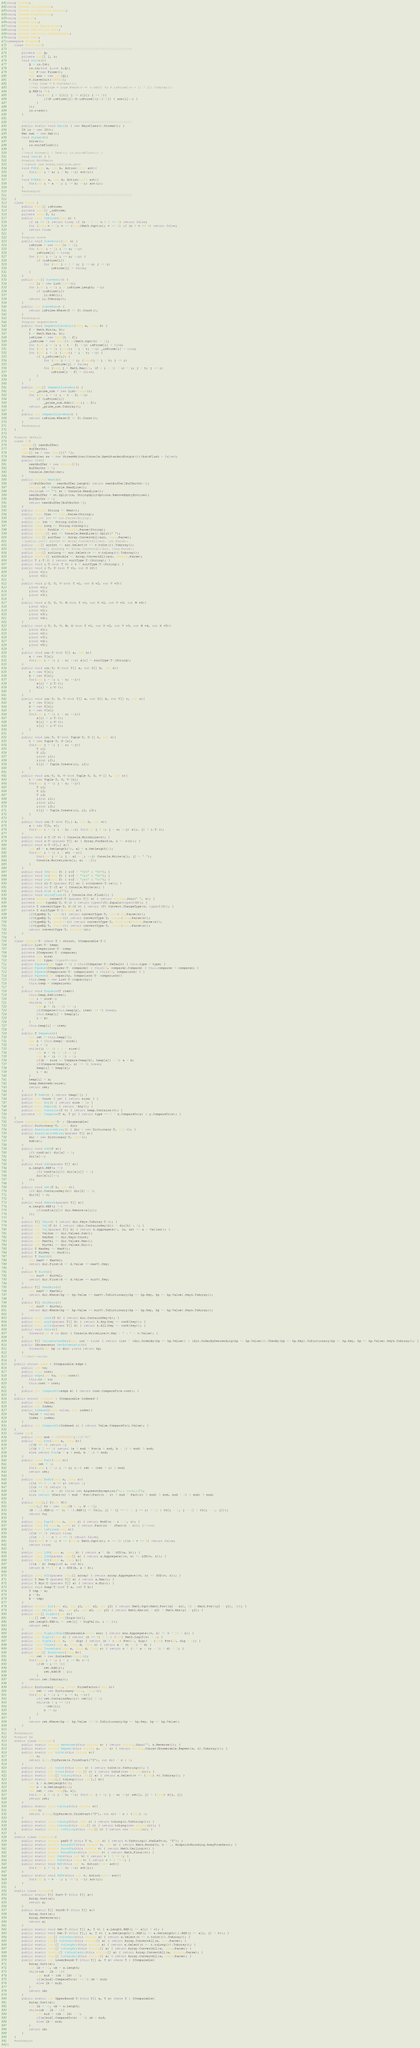Convert code to text. <code><loc_0><loc_0><loc_500><loc_500><_C#_>using System;
using System.Collections;
using System.Collections.Generic;
using System.Diagnostics;
using System.IO;
using System.Linq;
using System.Linq.Expressions;
using System.Reflection.Emit;
using System.Security.Cryptography;
using System.Text;
namespace Program{
    class MainClass{
        ////////////////////////////////////////////////////////////
        private int Q;
        private int[] l, r;
        void Solve(){
            Q = io.Int;
            io.ini(out l,out r,Q);
            var P=new Prime();
            var ans = new int[Q];
            P.SieveInit(100001);
            //var hoge = P.SieveArr();
            //var hogehoge = hoge.Where(v => v.Odd() && P.isPrime[(v + 1) / 2]).ToArray();           
            Q.REP(i =>{
                for(int j = l[i]; j <= r[i]; j += 2){
                    if(P.isPrime[j]&&P.isPrime[(j+1)/2]) { ans[i]++; }    
                }                
            });
            io.o(ans);
        }             

        ////////////////////////////////////////////////////////////
        public static void Main() { new MainClass().Stream(); }
        IO io = new IO();
        Mat mat = new Mat();
        void Stream(){
            Solve();
            io.writeFlush();
        }
        //void Stream() { Test(); io.writeFlush(); }
        void Test() { }
        #region MockMacro
        //cannot use break,continue,goto
        void FOR(int a, int b, Action<int> act){
            for(int i = a; i < b; ++i) act(i);
        }
        void FORR(int a, int b, Action<int> act){
            for(int i = a - 1; i >= b; --i) act(i);
        }
        #endregion
        ////////////////////////////////////////////////////////////
    }
    class Prime {
        public bool[] isPrime;
        private bool[] _isPrime;
        private long f, t;
        public bool IsPrime(long n) {
            if (n == 2) return true; if (n < 2 || n % 2 == 0) return false;
            for (long v = 3; v <= (long)Math.Sqrt(n); v += 2) if (n % v == 0) return false;
            return true;
        }
        #region sieve
        public void SieveInit(int n) {
            isPrime = new bool[n + 1];
            for (int i = 2; i <= n; ++i)
                isPrime[i] = true;
            for (int i = 2; i <= n; ++i) {
                if (isPrime[i])
                    for (int j = 2 * i; j <= n; j += i)
                        isPrime[j] = false;
            }
        }
        public int[] SieveArr() {
            var li = new List<int>();
            for (int i = 0; i < isPrime.Length; ++i)
                if (isPrime[i])
                    li.Add(i);
            return li.ToArray();
        }
        public int SieveNum() {
            return isPrime.Where(f => f).Count();
        }
        #endregion
        #region segmentSeve
        public void SegmentSieveInit(long a, long b) {
            f = Math.Min(a, b);
            t = Math.Max(a, b);
            isPrime = new bool[t - f];
            _isPrime = new bool[(int)Math.Sqrt(t) + 1];
            for (int i = 0; i < t - f; ++i) isPrime[i] = true;
            for (int i = 0; (long)i * i < t; ++i) _isPrime[i] = true;
            for (int i = 2; (long)i * i < t; ++i) {
                if (_isPrime[i]) {
                    for (int j = 2 * i; (long)j * j < t; j += i)
                        _isPrime[j] = false;
                    for (long j = Math.Max(2L, (f + i - 1) / i) * i; j < t; j += i)
                        isPrime[j - f] = false;
                }
            }
        }
        public long[] SegmentSieveArr() {
            var _prime_num = new List<long>();
            for (int i = 0; i < t - f; ++i)
                if (isPrime[i])
                    _prime_num.Add((long)i + f);
            return _prime_num.ToArray();
        }
        public int SegmentSieveNum() {
            return isPrime.Where(f => f).Count();
        }
        #endregion
    }

    #region default
    class IO{
        string[] nextBuffer;
        int BufferCnt;
        char[] cs = new char[]{' '};
        StreamWriter sw = new StreamWriter(Console.OpenStandardOutput()){AutoFlush = false};
        public IO(){
            nextBuffer = new string[0];
            BufferCnt = 0;
            Console.SetOut(sw);
        }
        public string Next(){
            if(BufferCnt < nextBuffer.Length) return nextBuffer[BufferCnt++];
            string st = Console.ReadLine();
            while(st == "") st = Console.ReadLine();
            nextBuffer = st.Split(cs, StringSplitOptions.RemoveEmptyEntries);
            BufferCnt = 0;
            return nextBuffer[BufferCnt++];
        }
        public string String => Next();
        public char Char => char.Parse(String);
        //public int Int => int.Parse(String);
        public int Int => String.toInt();
        public long Long => String.toLong();
        public double Double => double.Parse(String);
        public string[] arr => Console.ReadLine().Split(' ');
        public char[] arrChar => Array.ConvertAll(arr, char.Parse);
        //public int[] arrInt => Array.ConvertAll(arr, int.Parse);
        public int[] arrInt => arr.Select(v => v.toInt()).ToArray();
        //public long[] arrLong => Array.ConvertAll(arr, long.Parse);
        public long[] arrLong => arr.Select(v => v.toLong()).ToArray();
        public double[] arrDouble => Array.ConvertAll(arr, double.Parse);
        public T i<T>() { return suitType<T>(String); }
        public void i<T>(out T v) { v = suitType<T>(String); }
        public void i<T, U>(out T v1, out U v2){
            i(out v1);
            i(out v2);
        }
        public void i<T, U, V>(out T v1, out U v2, out V v3){
            i(out v1);
            i(out v2);
            i(out v3);
        }
        public void i<T, U, V, W>(out T v1, out U v2, out V v3, out W v4){
            i(out v1);
            i(out v2);
            i(out v3);
            i(out v4);
        }
        public void i<T, U, V, W, X>(out T v1, out U v2, out V v3, out W v4, out X v5){
            i(out v1);
            i(out v2);
            i(out v3);
            i(out v4);
            i(out v5);
        }
        public void ini<T>(out T[] a, int n){
            a = new T[n];
            for(int i = 0; i < n; ++i) a[i] = suitType<T>(String);
        }
        public void ini<T, U>(out T[] a, out U[] b, int n){
            a = new T[n];
            b = new U[n];
            for(int i = 0; i < n; ++i){
                a[i] = i<T>();
                b[i] = i<U>();
            }
        }
        public void ini<T, U, V>(out T[] a, out U[] b, out V[] c, int n){
            a = new T[n];
            b = new U[n];
            c = new V[n];
            for(int i = 0; i < n; ++i){
                a[i] = i<T>();
                b[i] = i<U>();
                c[i] = i<V>();
            }
        }
        public void ini<T, U>(out Tuple<T, U>[] t, int n){
            t = new Tuple<T, U>[n];
            for(int j = 0; j < n; ++j){
                T i1;
                U i2;
                i(out i1);
                i(out i2);
                t[j] = Tuple.Create(i1, i2);
            }
        }
        public void ini<T, U, V>(out Tuple<T, U, V>[] t, int n){
            t = new Tuple<T, U, V>[n];
            for(int j = 0; j < n; ++j){
                T i1;
                U i2;
                V i3;
                i(out i1);
                i(out i2);
                i(out i3);
                t[j] = Tuple.Create(i1, i2, i3);
            }
        }
        public void ini<T>(out T[,] a, int h, int w){
            a = new T[h, w];
            for(int i = 0; i < h; ++i) for(int j = 0; j < w; ++j) a[i, j] = i<T>();
        }
        public void o<T>(T v) { Console.WriteLine(v); }
        public void o<T>(params T[] a) { Array.ForEach(a, n => o(n)); }
        public void o<T>(T[,] a){
            int a0 = a.GetLength(0), a1 = a.GetLength(1);
            for(int i = 0; i < a0; ++i){
                for(int j = 0; j < a1 - 1; ++j) Console.Write(a[i, j] + " ");
                Console.WriteLine(a[i, a1 - 1]);
            }
        }
        public void YN(bool f) { o(f ? "YES" : "NO"); }
        public void Yn(bool f) { o(f ? "Yes" : "No"); }
        public void yn(bool f) { o(f ? "yes" : "no"); }
        public void ol<T>(params T[] a) { o(connect<T>(a)); }
        public void or<T>(T a) { Console.Write(a); }
        public void br() { o(""); }
        public void writeFlush() { Console.Out.Flush(); }
        private string connect<T>(params T[] s) { return string.Join(" ", s); }
        private bool typeEQ<T, U>() { return typeof(T).Equals(typeof(U)); }
        private T convertType<T, U>(U v) { return (T) Convert.ChangeType(v, typeof(T)); }
        private T suitType<T>(string s){
            if(typeEQ<T, int>()) return convertType<T, int>(int.Parse(s));
            if(typeEQ<T, long>()) return convertType<T, long>(long.Parse(s));
            if(typeEQ<T, double>()) return convertType<T, double>(double.Parse(s));
            if(typeEQ<T, char>()) return convertType<T, char>(char.Parse(s));
            return convertType<T, string>(s);
        }
    }
    class PQueue<T> where T : struct, IComparable<T>{
        public List<T> heap;
        private Comparison<T> comp;
        private IComparer<T> comparer;
        private int size;
        private int type;//type=0->min
        public PQueue(int type = 0) : this(Comparer<T>.Default) { this.type = type; }
        public PQueue(IComparer<T> comparer) : this(16, comparer.Compare) { this.comparer = comparer; }
        public PQueue(Comparison<T> comparison) : this(16, comparison) { }
        public PQueue(int capacity, Comparison<T> comparison){
            this.heap = new List<T>(capacity);
            this.comp = comparison;
        }
        public void Enqueue(T item){
            this.heap.Add(item);
            var i = size++;
            while(i > 0){
                var p = (i - 1) >> 1;
                if(Compare(this.heap[p], item) <= 0) break;
                this.heap[i] = heap[p];
                i = p;
            }
            this.heap[i] = item;
        }
        public T Dequeue(){
            var ret = this.heap[0];
            var x = this.heap[--size];
            var i = 0;
            while((i << 1) + 1 < size){
                var a = (i << 1) + 1;
                var b = (i << 1) + 2;
                if(b < size && Compare(heap[b], heap[a]) < 0) a = b;
                if(Compare(heap[a], x) >= 0) break;
                heap[i] = heap[a];
                i = a;
            }
            heap[i] = x;
            heap.RemoveAt(size);
            return ret;
        }
        public T Peek() { return heap[0]; }
        public int Count { get { return size; } }
        public bool Any() { return size > 0; }
        public bool Empty() { return !Any(); }
        public bool Contains(T v) { return heap.Contains(v); }
        private int Compare(T x, T y) { return type == 0 ? x.CompareTo(y) : y.CompareTo(x); }
    }
    class AssociativeArray<T> : IEnumerable{
        public Dictionary<T, int> dic;
        public AssociativeArray() { dic = new Dictionary<T, int>(); }
        public AssociativeArray(params T[] a){
            dic = new Dictionary<T, int>();
            Add(a);
        }
        public void Add(T a){
            if(!conK(a)) dic[a] = 0;
            dic[a]++;
        }
        public void Add(params T[] a){
            a.Length.REP(i =>{
                if(!conK(a[i])) dic[a[i]] = 0;
                dic[a[i]]++;
            });
        }
        public void Set(T k, int v){
            if(!dic.ContainsKey(k)) dic[k] = 0;
            dic[k] = v;
        }
        public void Remove(params T[] a){
            a.Length.REP(i =>{
                if(conK(a[i])) dic.Remove(a[i]);
            });
        }
        public T[] Keys() { return dic.Keys.ToArray<T>(); }
        public int Val(T k) { return (dic.ContainsKey(k)) ? dic[k] : 0; }
        public int Val(params T[] k) { return k.Aggregate(0, (x, xs) => x + Val(xs)); }
        public int ValSum => dic.Values.Sum();
        public int KeyNum => dic.Keys.Count;
        public int MaxVal => dic.Values.Max();
        public int MinVal => dic.Values.Min();
        public T MaxKey => MaxK();
        public T MinKey => MinK();
        public T MaxK(){
            var maxV = MaxVal;
            return dic.First(d => d.Value == maxV).Key;
        }
        public T MinK(){
            var minV = MinVal;
            return dic.First(d => d.Value == minV).Key;
        }
        public T[] MaxKeys(){
            var maxV = MaxVal;
            return dic.Where(kp => kp.Value == maxV).ToDictionary(kp => kp.Key, kp => kp.Value).Keys.ToArray();
        }
        public T[] MinKeys(){
            var minV = MinVal;
            return dic.Where(kp => kp.Value == minV).ToDictionary(kp => kp.Key, kp => kp.Value).Keys.ToArray();
        }
        public bool conK(T k) { return dic.ContainsKey(k); }
        public bool anyK(params T[] k) { return k.Any(key => conK(key)); }
        public bool allK(params T[] k) { return k.All(key => conK(key)); }
        public void Show(){
            foreach(var v in dic) { Console.WriteLine(v.Key + " : " + v.Value); }
        }
        public T[] ValueSortedKey(bool inc = true) { return (inc ? (dic.OrderBy(kp => kp.Value)) : (dic.OrderByDescending(kp => kp.Value))).ThenBy(kp => kp.Key).ToDictionary(kp => kp.Key, kp => kp.Value).Keys.ToArray(); }
        public IEnumerator GetEnumerator(){
            foreach(var kp in dic) yield return kp;
        }
        //:sort->array
    }
    public struct edge : IComparable<edge>{
        public int to;
        public long cost;
        public edge(int to, long cost){
            this.to = to;
            this.cost = cost;
        }
        public int CompareTo(edge e) { return cost.CompareTo(e.cost); }
    }
    public struct Indexed : IComparable<Indexed>{
        public long Value;
        public int Index;
        public Indexed(long value, int index){
            Value = value;
            Index = index;
        }
        public int CompareTo(Indexed i) { return Value.CompareTo(i.Value); }
    }
    class Mat{
        public long mod = 1000000007;//10^9+7
        public long Pow(long a, long b){
            if(b == 0) return 1;
            if(b % 2 == 1) return (a % mod * Pow(a % mod, b - 1) % mod) % mod;
            else return Pow(a * a % mod, b / 2) % mod;
        }
        public long Fact(long n){
            long ret = 1;
            for(long i = 1; i <= n; i++) ret = (ret * i) % mod;
            return ret;
        }
        public long ModC(long n, long r){
            if(r == 0 || n == r) return 1;
            if(n == 0) return 0;
            if(n < 0 || n < r) throw new ArgumentException("n,r invalid");
            else return (Fact(n) % mod * Pow((Fact(n - r) % mod * Fact(r) % mod) % mod, mod - 2) % mod) % mod;
        }
        public long[,] C(int N){
            long[,] Co = new long[N + 1, N + 1];
            (N + 1).REP(i => (i + 1).REP(j => Co[i, j] = (j == 0 || j == i) ? 1L : Co[i - 1, j - 1] + Co[i - 1, j]));
            return Co;
        }
        public long DupC(long n, long r) { return ModC(n + r - 1, r); }
        public long P(long n, long r) { return Fact(n) / (Fact(n - r)); }//test
        public bool isPrime(long n){
            if(n == 2) return true;
            if(n < 2 || n % 2 == 0) return false;
            for(long v = 3; v <= (long) Math.Sqrt(n); v += 2) if(n % v == 0) return false;
            return true;
        }
        public long LCM(long a, long b) { return a * (b / GCD(a, b)); }
        public long LCM(params long[] a) { return a.Aggregate((v, n) => LCM(v, n)); }
        public long GCD(long a, long b){
            if(a < b) Swap(ref a, ref b);
            return b == 0 ? a : GCD(b, a % b);
        }
        public long GCD(params long[] array) { return array.Aggregate((v, n) => GCD(v, n)); }
        public T Max<T>(params T[] a) { return a.Max(); }
        public T Min<T>(params T[] a) { return a.Min(); }
        public void Swap<T>(ref T a, ref T b){
            T tmp = a;
            a = b;
            b = tmp;
        }
        public double Dis(int x1, int y1, int x2, int y2) { return Math.Sqrt(Math.Pow((x2 - x1), 2) + Math.Pow((y2 - y1), 2)); }
        public int mDis(int x1, int y1, int x2, int y2) { return Math.Abs(x1 - x2) + Math.Abs(y1 - y2); }
        public int[] DigArr(int n){
            int[] ret = new int[Digit(n)];
            ret.Length.REP(i => ret[i] = DigVal(n, i + 1));
            return ret;
        }
        public long DigArr2Num(IEnumerable<int> enu) { return enu.Aggregate((v, n) => v * 10 + n); }
        public int Digit(long n) { return (n == 0) ? 1 : (int) Math.Log10(n) + 1; }
        public int DigVal(int n, int dig) { return (n % (int) Pow(10, dig)) / (int) Pow(10, dig - 1); }
        public long Tousa(long a, long d, long n) { return a + (n - 1) * d; }
        public long TousaSum(long a, long d, long n) { return n * (2 * a + (n - 1) * d) / 2; }
        public long[] EnuDivsor(long N){
            var ret = new SortedSet<long>();
            for(long i = 1; i * i <= N; i++)
                if(N % i == 0){
                    ret.Add(i);
                    ret.Add(N / i);
                }
            return ret.ToArray();
        }
        public Dictionary<long, long> PrimeFactor(long n){
            var ret = new Dictionary<long, long>();
            for(int i = 2; i * i <= n; ++i){
                if(!ret.ContainsKey(i)) ret[i] = 0;
                while(n % i == 0){
                    ++ret[i];
                    n /= i;
                }
            }
            return ret.Where(kp => kp.Value != 0).ToDictionary(kp => kp.Key, kp => kp.Value);
        }
    }
    #endregion
    #region Ex
    static class StringEX{
        public static string Reversed(this string s) { return string.Join("", s.Reverse()); }
        public static string Repeat(this string s, int n) { return string.Concat(Enumerable.Repeat(s, n).ToArray()); }
        public static int toInt(this string s){
            int n;
            return (int.TryParse(s.TrimStart('0'), out n)) ? n : 0;
        }
        public static int toInt(this char c) { return toInt(c.ToString()); }
        public static int toInt(this char[] c) { return toInt(new string(c)); }
        public static long[] toLong(this int[] a) { return a.Select(v => (long) v).ToArray(); }
        public static long[,] toLong(this int[,] m){
            var h = m.GetLength(0);
            var w = m.GetLength(1);
            var ret = new long[h, w];
            for(int i = 0; i < h; ++i) for(int j = 0; j < w; ++j) ret[i, j] = (long) m[i, j];
            return ret;
        }
        public static long toLong(this string s){
            long n;
            return (long.TryParse(s.TrimStart('0'), out n)) ? n : (long) 0;
        }
        public static long toLong(this char c) { return toLong(c.ToString()); }
        public static long toLong(this char[] c) { return toLong(new string(c)); }
        public static string toString(this char[] c) { return new string(c); }
    }
    static class NumericEx{
        public static string pad0<T>(this T v, int n) { return v.ToString().PadLeft(n, '0'); }
        public static double RoundOff(this double v, int n) { return Math.Round(v, n - 1, MidpointRounding.AwayFromZero); }
        public static double RoundUp(this double v) { return Math.Ceiling(v); }
        public static double RoundDown(this double v) { return Math.Floor(v); }
        public static bool Odd(this int v) { return v % 2 != 0; }
        public static bool Odd(this long v) { return v % 2 != 0; }
        public static void REP(this int v, Action<int> act){
            for(int i = 0; i < v; ++i) act(i);
        }
        public static void REPR(this int v, Action<int> act){
            for(int i = v - 1; i >= 0; --i) act(i);
        }
    }
    static class ArrayEX{
        public static T[] Sort<T>(this T[] a){
            Array.Sort(a);
            return a;
        }
        public static T[] SortR<T>(this T[] a){
            Array.Sort(a);
            Array.Reverse(a);
            return a;
        }
        public static void Set<T>(this T[] a, T v) { a.Length.REP(i => a[i] = v); }
        public static void Set<T>(this T[,] a, T v) { a.GetLength(0).REP(i => a.GetLength(1).REP(j => a[i, j] = v)); }
        public static int[] toIntArr(this string a) { return a.Select(c => c.toInt()).ToArray(); }
        public static int[] toIntArr(this string[] a) { return Array.ConvertAll(a, int.Parse); }
        public static long[] toLongArr(this string a) { return a.Select(c => c.toLong()).ToArray(); }
        public static long[] toLongArr(this string[] a) { return Array.ConvertAll(a, long.Parse); }
        public static double[] toDoubleArr(this string[] a) { return Array.ConvertAll(a, double.Parse); }
        public static char[] toCharArr(this string[] a) { return Array.ConvertAll(a, char.Parse); }
        public static int LowerBound<T>(this T[] a, T x) where T : IComparable{
            Array.Sort(a);
            int lb = -1, ub = a.Length;
            while(ub - lb > 1){
                int mid = (ub + lb) / 2;
                if(a[mid].CompareTo(x) >= 0) ub = mid;
                else lb = mid;
            }
            return ub;
        }
        public static int UpperBound<T>(this T[] a, T x) where T : IComparable{
            Array.Sort(a);
            int lb = -1, ub = a.Length;
            while(ub - lb > 1){
                int mid = (ub + lb) / 2;
                if(a[mid].CompareTo(x) > 0) ub = mid;
                else lb = mid;
            }
            return ub;
        }
    }
    #endregion
}
</code> 